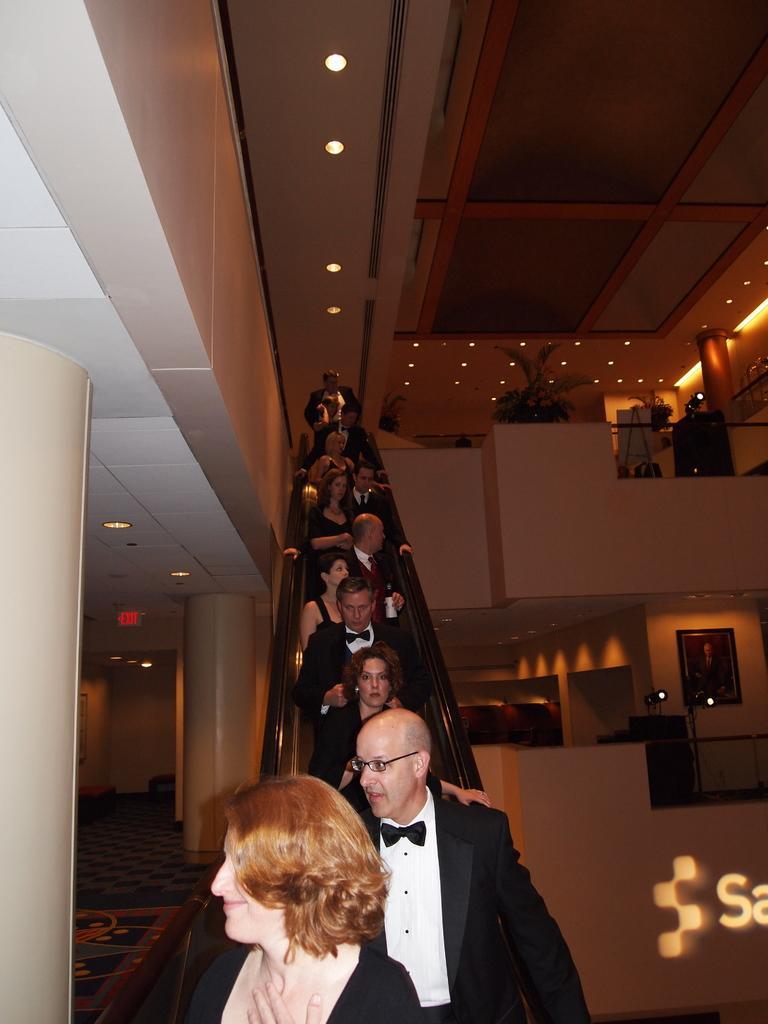Describe this image in one or two sentences. In this image we can see a group of people standing on the staircase. One person is wearing spectacles. To the right side of the image we can see some text, photo frame on the wall, some plants. In the background, we can see metal barricades, a group of lights and some pillars. 